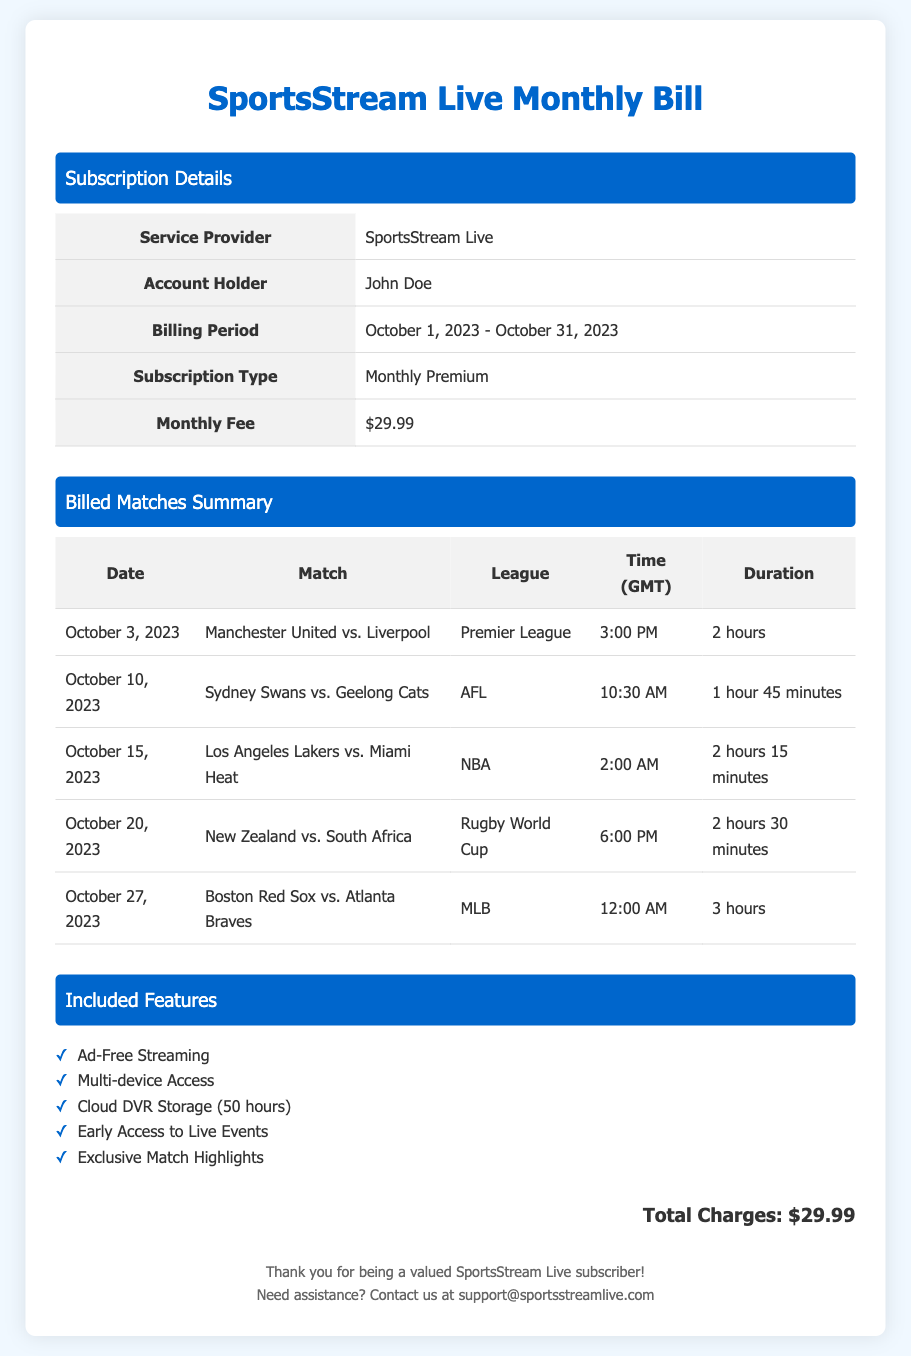What is the account holder's name? The document states the account holder's name as "John Doe."
Answer: John Doe What is the subscription type? The subscription type mentioned in the bill is "Monthly Premium."
Answer: Monthly Premium What is the billing period? The document specifies the billing period as "October 1, 2023 - October 31, 2023."
Answer: October 1, 2023 - October 31, 2023 How many matches are listed in the billed matches summary? The summary table lists a total of five matches.
Answer: 5 What is the duration of the match on October 20, 2023? The document states that the duration of the match "New Zealand vs. South Africa" is "2 hours 30 minutes."
Answer: 2 hours 30 minutes What feature allows you to watch matches without interruptions? The feature that provides this service is "Ad-Free Streaming."
Answer: Ad-Free Streaming What was the total charge for the subscription? The total charge is stated at the bottom of the bill as "$29.99."
Answer: $29.99 At what time did the match between the Los Angeles Lakers and Miami Heat start? The document specifies the match started at "2:00 AM."
Answer: 2:00 AM Which league was the match featuring Manchester United part of? The document mentions that this match was part of the "Premier League."
Answer: Premier League 